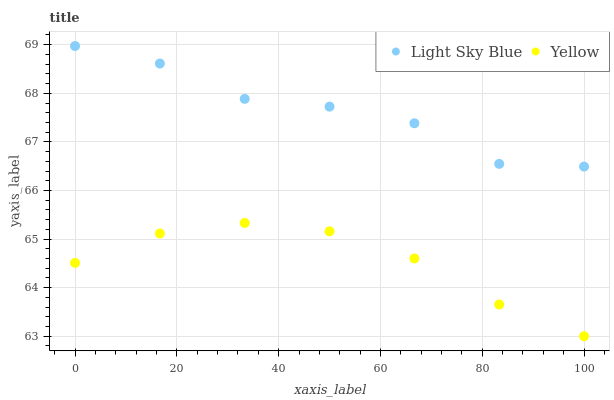Does Yellow have the minimum area under the curve?
Answer yes or no. Yes. Does Light Sky Blue have the maximum area under the curve?
Answer yes or no. Yes. Does Yellow have the maximum area under the curve?
Answer yes or no. No. Is Yellow the smoothest?
Answer yes or no. Yes. Is Light Sky Blue the roughest?
Answer yes or no. Yes. Is Yellow the roughest?
Answer yes or no. No. Does Yellow have the lowest value?
Answer yes or no. Yes. Does Light Sky Blue have the highest value?
Answer yes or no. Yes. Does Yellow have the highest value?
Answer yes or no. No. Is Yellow less than Light Sky Blue?
Answer yes or no. Yes. Is Light Sky Blue greater than Yellow?
Answer yes or no. Yes. Does Yellow intersect Light Sky Blue?
Answer yes or no. No. 